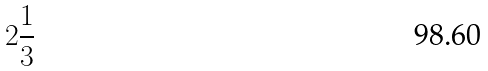<formula> <loc_0><loc_0><loc_500><loc_500>2 \frac { 1 } { 3 }</formula> 